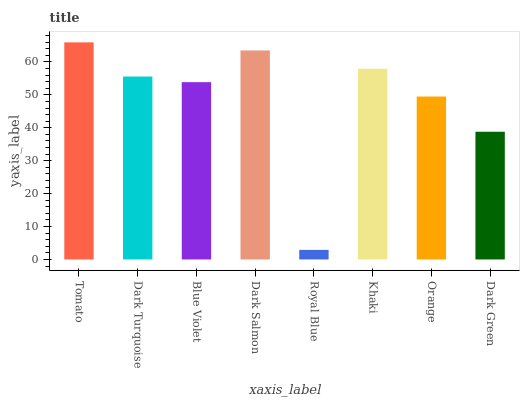Is Royal Blue the minimum?
Answer yes or no. Yes. Is Tomato the maximum?
Answer yes or no. Yes. Is Dark Turquoise the minimum?
Answer yes or no. No. Is Dark Turquoise the maximum?
Answer yes or no. No. Is Tomato greater than Dark Turquoise?
Answer yes or no. Yes. Is Dark Turquoise less than Tomato?
Answer yes or no. Yes. Is Dark Turquoise greater than Tomato?
Answer yes or no. No. Is Tomato less than Dark Turquoise?
Answer yes or no. No. Is Dark Turquoise the high median?
Answer yes or no. Yes. Is Blue Violet the low median?
Answer yes or no. Yes. Is Dark Green the high median?
Answer yes or no. No. Is Khaki the low median?
Answer yes or no. No. 